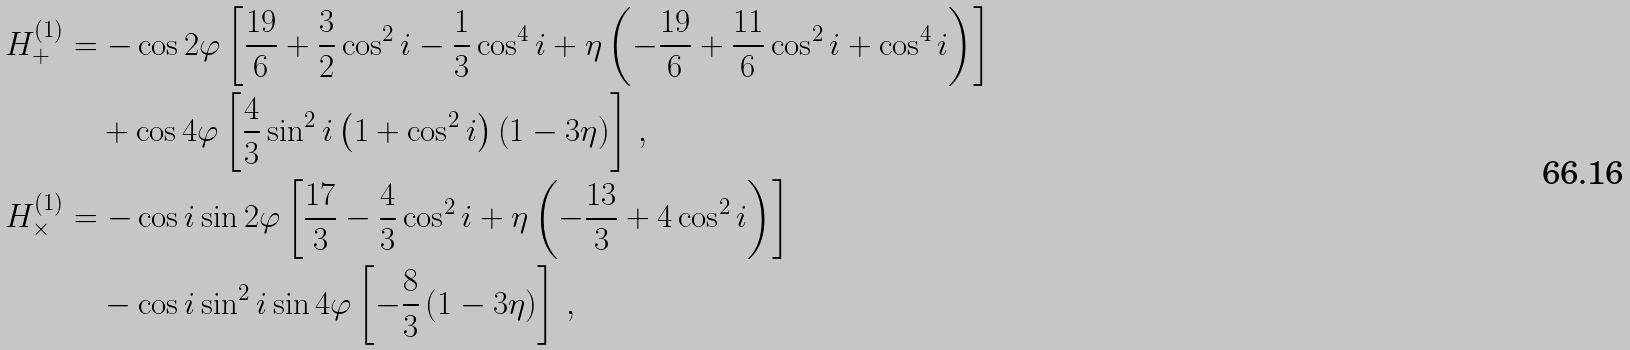<formula> <loc_0><loc_0><loc_500><loc_500>H ^ { ( 1 ) } _ { + } & = - \cos 2 \varphi \left [ \frac { 1 9 } { 6 } + \frac { 3 } { 2 } \cos ^ { 2 } i - \frac { 1 } { 3 } \cos ^ { 4 } i + \eta \left ( - \frac { 1 9 } { 6 } + \frac { 1 1 } { 6 } \cos ^ { 2 } i + \cos ^ { 4 } i \right ) \right ] \\ & \quad + \cos 4 \varphi \left [ \frac { 4 } { 3 } \sin ^ { 2 } i \left ( 1 + \cos ^ { 2 } i \right ) \left ( 1 - 3 \eta \right ) \right ] \, , \\ H ^ { ( 1 ) } _ { \times } & = - \cos i \sin 2 \varphi \left [ \frac { 1 7 } { 3 } - \frac { 4 } { 3 } \cos ^ { 2 } i + \eta \left ( - \frac { 1 3 } { 3 } + 4 \cos ^ { 2 } i \right ) \right ] \\ & \quad - \cos i \sin ^ { 2 } i \sin 4 \varphi \left [ - \frac { 8 } { 3 } \left ( 1 - 3 \eta \right ) \right ] \, ,</formula> 